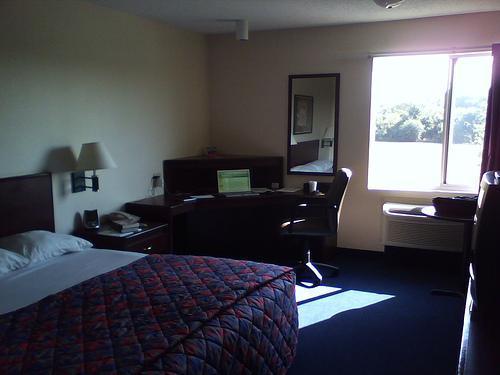How many chairs are visible?
Give a very brief answer. 1. How many beds are in the room?
Give a very brief answer. 1. 